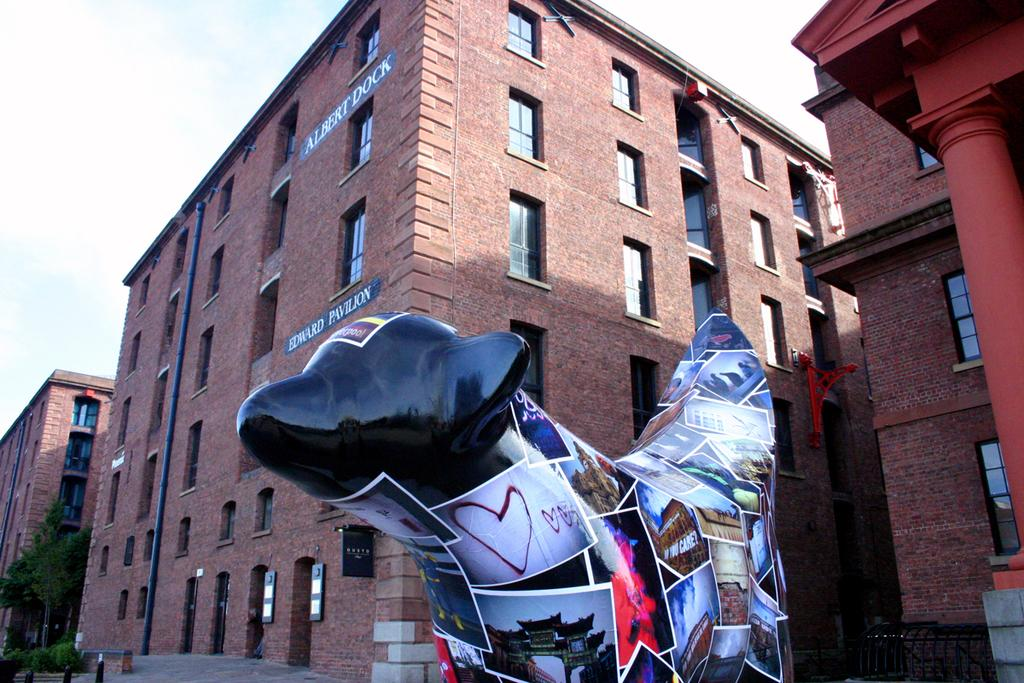What is the main subject of the image? There is a statue in the image. What is placed on the statue? Papers are placed on the statue. What can be seen in the background of the image? There are buildings, trees, and the sky visible in the background of the image. How does the statue help with the digestion of food in the image? The statue does not have any role in the digestion of food; it is a stationary object in the image. 